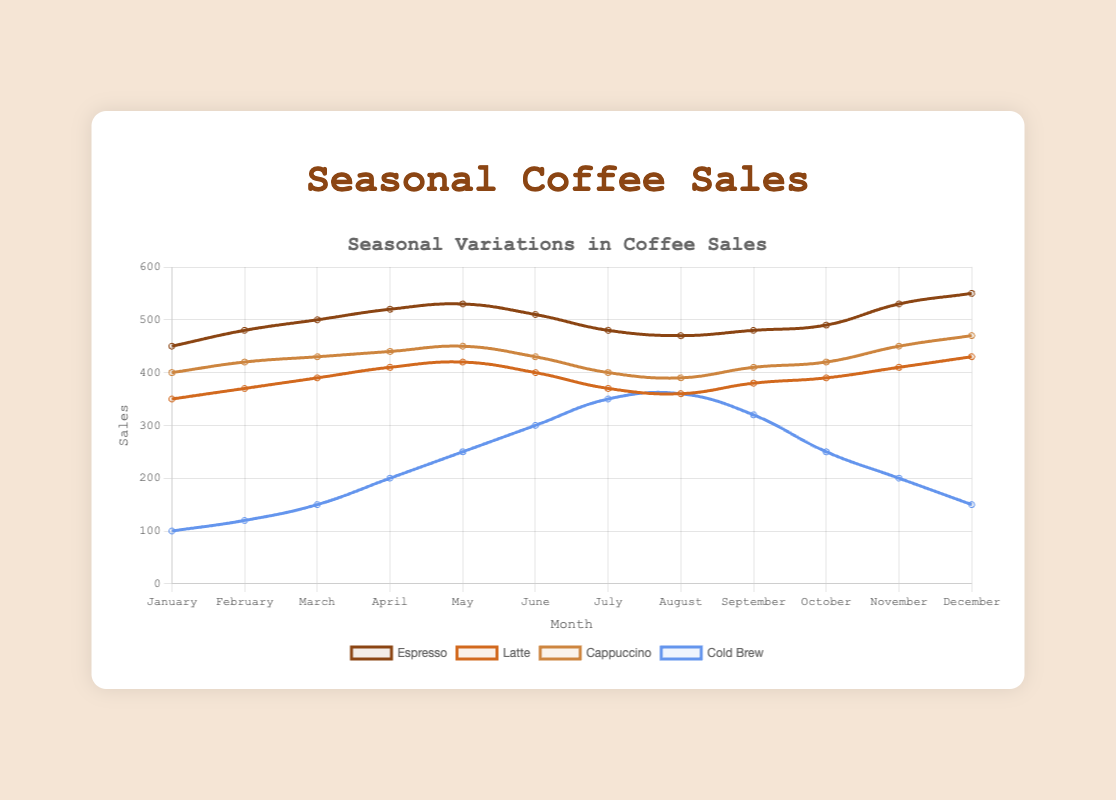What month has the highest espresso sales? By looking at the espresso sales curve, we can see that the highest point is in December with 550 sales.
Answer: December How do the cold brew sales in July compare to those in January? Observing the cold brew sales line, in July, it reaches 350, whereas in January, it is only 100. Thus, July has significantly higher sales.
Answer: July has higher sales Which type of coffee experiences the greatest increase in sales from January to December? To determine this, we need to calculate the difference in sales for each coffee type from January to December. The differences are: Espresso (550-450=100), Latte (430-350=80), Cappuccino (470-400=70), Cold Brew (150-100=50). Espresso has the greatest increase.
Answer: Espresso What is the average sales figure for lattes throughout the year? To find this, sum up the monthly latte sales figures and divide by 12. Sum = 350 + 370 + 390 + 410 + 420 + 400 + 370 + 360 + 380 + 390 + 410 + 430 = 4780. Average = 4780 / 12 ≈ 398.33.
Answer: 398.33 In which month is the difference between espresso and cold brew sales the smallest? To identify this, we calculate the difference for each month and observe their values: January (350), February (360), March (350), April (320), May (280), June (210), July (130), August (110), September (160), October (240), November (330), December (400). The smallest difference is in August at 110.
Answer: August What is the median value of cappuccino sales across the year? First, list the cappuccino sales figures in order: 390, 400, 410, 420, 420, 430, 430, 440, 450, 450, 470. With 12 values, the median is the average of the 6th and 7th values, (420 + 430) / 2 = 425.
Answer: 425 Which coffee type has the most fluctuating sales and how can you tell? By visually assessing the curves, the cold brew line has the greatest variance, rising sharply from January to July and then decreasing significantly towards December. This shows the most fluctuation in sales.
Answer: Cold Brew In which month do all types of coffee show an increase in sales compared to the previous month? Comparing sales figures month by month, all types show an increase from February to March and from January to February. Upon verifying data, the consistent increment is seen from February to March.
Answer: March How do latte sales in the summer months (June, July, and August) compare to latte sales in the winter months (December, January, February)? Calculate average sales for summer (June, July, August): (400 + 370 + 360)/3 ≈ 376.67, and for winter (December, January, February): (430 + 350 + 370)/3 ≈ 383.33. Winter sales are slightly higher.
Answer: Winter sales are higher What trend do you observe for cold brew sales from January to December? The cold brew line starts low in January, increases consistently till reaching the peak in August, and then declines back towards December.
Answer: Rise then fall 